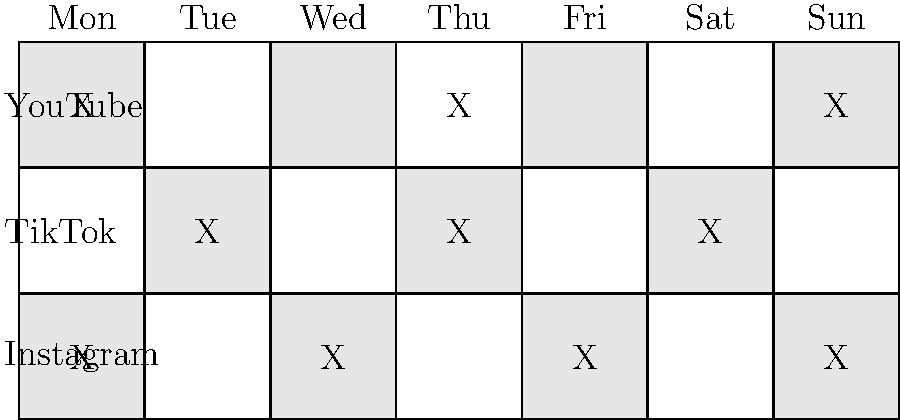Based on the weekly posting schedule shown in the chart, which platform requires the most frequent posts, and how many times per week should you post on it to maximize your social media influence? To determine the platform with the most frequent posts and the number of times to post per week, let's analyze the chart step-by-step:

1. Count the number of posts (marked with "X") for each platform:
   - Instagram: 4 posts (Monday, Wednesday, Friday, Sunday)
   - TikTok: 3 posts (Tuesday, Thursday, Saturday)
   - YouTube: 3 posts (Monday, Thursday, Sunday)

2. Compare the number of posts:
   - Instagram has the highest number of posts with 4 per week.
   - TikTok and YouTube both have 3 posts per week.

3. Identify the platform requiring the most frequent posts:
   - Instagram requires the most frequent posts with 4 per week.

4. Determine the posting frequency for Instagram:
   - Posts are scheduled for Monday, Wednesday, Friday, and Sunday.
   - This creates an every-other-day posting schedule, with a slight variation on the weekend.

5. Consider the impact on social media influence:
   - More frequent posting on Instagram can help maintain a consistent presence and engagement with followers.
   - The every-other-day schedule allows for content creation time while keeping the audience engaged.

Therefore, to maximize your social media influence, you should post on Instagram 4 times per week, following the schedule shown in the chart.
Answer: Instagram, 4 times per week 